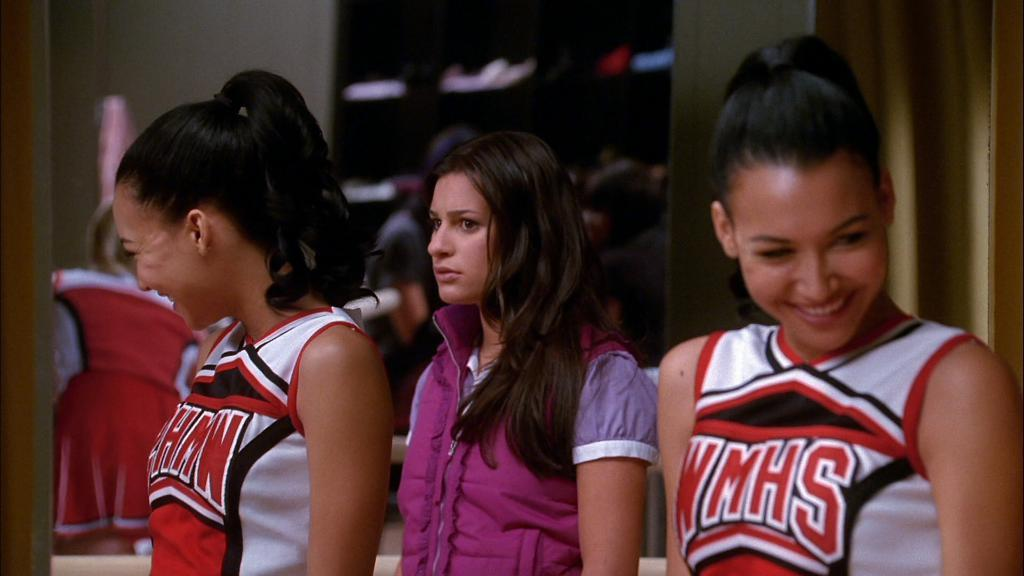<image>
Give a short and clear explanation of the subsequent image. A cheerleader from WMHS turns her head and laughs. 